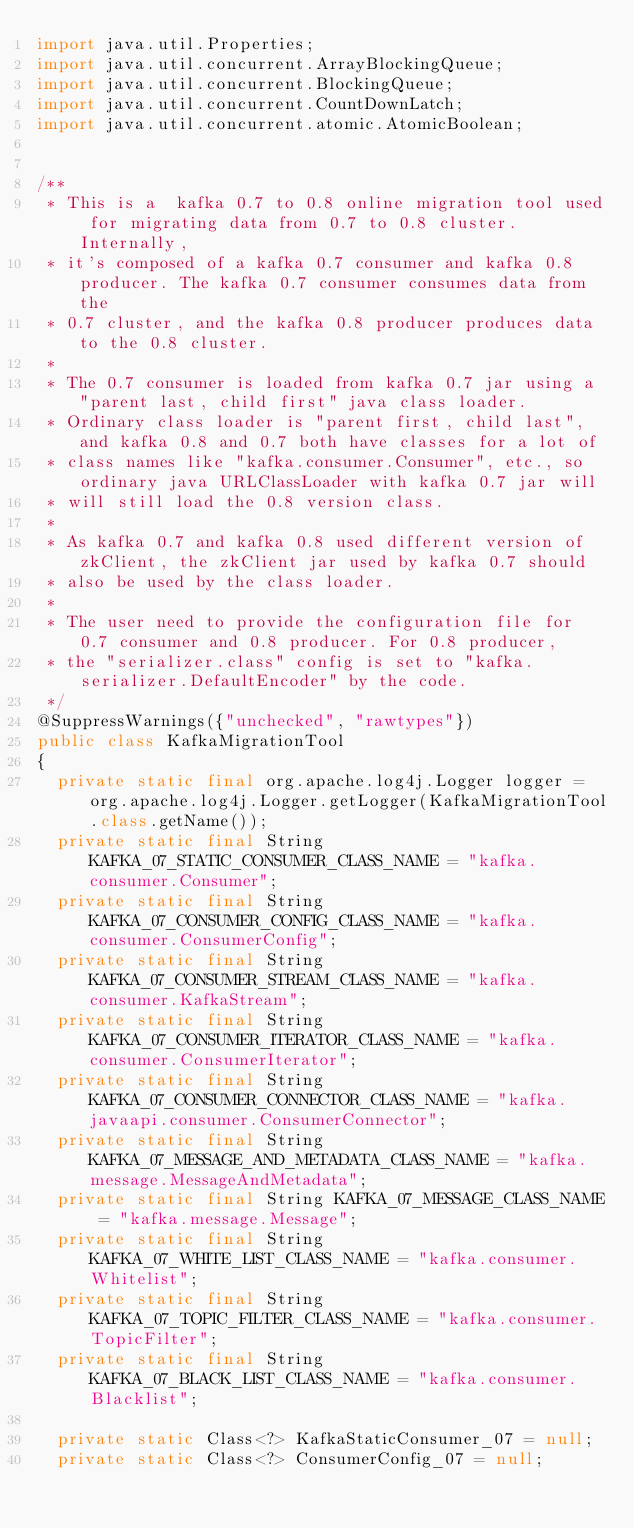Convert code to text. <code><loc_0><loc_0><loc_500><loc_500><_Java_>import java.util.Properties;
import java.util.concurrent.ArrayBlockingQueue;
import java.util.concurrent.BlockingQueue;
import java.util.concurrent.CountDownLatch;
import java.util.concurrent.atomic.AtomicBoolean;


/**
 * This is a  kafka 0.7 to 0.8 online migration tool used for migrating data from 0.7 to 0.8 cluster. Internally,
 * it's composed of a kafka 0.7 consumer and kafka 0.8 producer. The kafka 0.7 consumer consumes data from the
 * 0.7 cluster, and the kafka 0.8 producer produces data to the 0.8 cluster.
 *
 * The 0.7 consumer is loaded from kafka 0.7 jar using a "parent last, child first" java class loader.
 * Ordinary class loader is "parent first, child last", and kafka 0.8 and 0.7 both have classes for a lot of
 * class names like "kafka.consumer.Consumer", etc., so ordinary java URLClassLoader with kafka 0.7 jar will
 * will still load the 0.8 version class.
 *
 * As kafka 0.7 and kafka 0.8 used different version of zkClient, the zkClient jar used by kafka 0.7 should
 * also be used by the class loader.
 *
 * The user need to provide the configuration file for 0.7 consumer and 0.8 producer. For 0.8 producer,
 * the "serializer.class" config is set to "kafka.serializer.DefaultEncoder" by the code.
 */
@SuppressWarnings({"unchecked", "rawtypes"})
public class KafkaMigrationTool
{
  private static final org.apache.log4j.Logger logger = org.apache.log4j.Logger.getLogger(KafkaMigrationTool.class.getName());
  private static final String KAFKA_07_STATIC_CONSUMER_CLASS_NAME = "kafka.consumer.Consumer";
  private static final String KAFKA_07_CONSUMER_CONFIG_CLASS_NAME = "kafka.consumer.ConsumerConfig";
  private static final String KAFKA_07_CONSUMER_STREAM_CLASS_NAME = "kafka.consumer.KafkaStream";
  private static final String KAFKA_07_CONSUMER_ITERATOR_CLASS_NAME = "kafka.consumer.ConsumerIterator";
  private static final String KAFKA_07_CONSUMER_CONNECTOR_CLASS_NAME = "kafka.javaapi.consumer.ConsumerConnector";
  private static final String KAFKA_07_MESSAGE_AND_METADATA_CLASS_NAME = "kafka.message.MessageAndMetadata";
  private static final String KAFKA_07_MESSAGE_CLASS_NAME = "kafka.message.Message";
  private static final String KAFKA_07_WHITE_LIST_CLASS_NAME = "kafka.consumer.Whitelist";
  private static final String KAFKA_07_TOPIC_FILTER_CLASS_NAME = "kafka.consumer.TopicFilter";
  private static final String KAFKA_07_BLACK_LIST_CLASS_NAME = "kafka.consumer.Blacklist";

  private static Class<?> KafkaStaticConsumer_07 = null;
  private static Class<?> ConsumerConfig_07 = null;</code> 